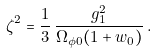Convert formula to latex. <formula><loc_0><loc_0><loc_500><loc_500>\zeta ^ { 2 } = \frac { 1 } { 3 } \, \frac { g _ { 1 } ^ { 2 } } { \Omega _ { \phi 0 } ( 1 + w _ { 0 } ) } \, .</formula> 